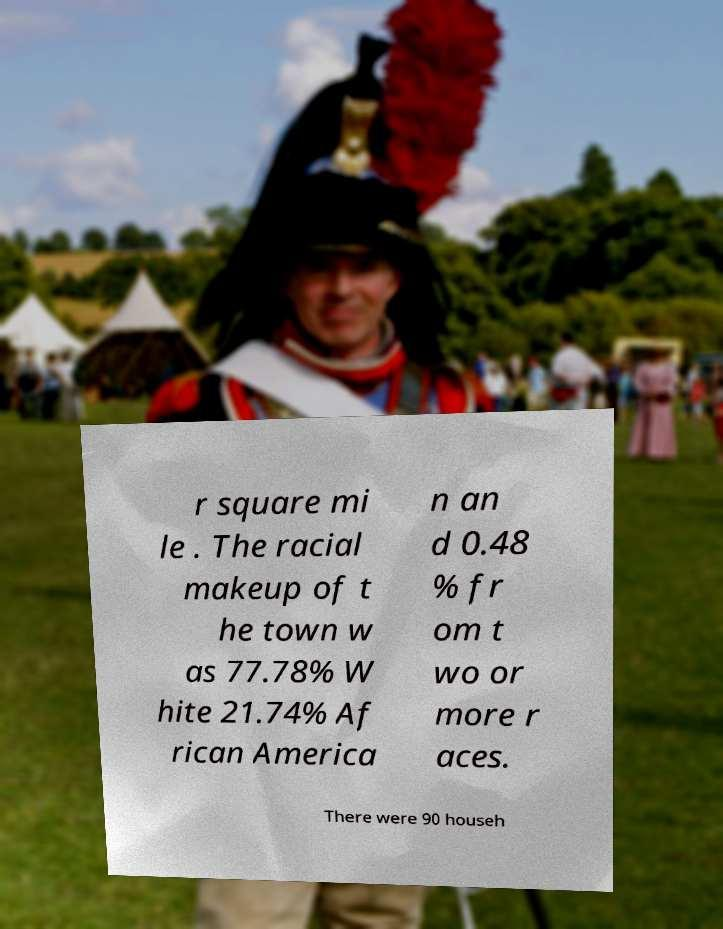Please read and relay the text visible in this image. What does it say? r square mi le . The racial makeup of t he town w as 77.78% W hite 21.74% Af rican America n an d 0.48 % fr om t wo or more r aces. There were 90 househ 